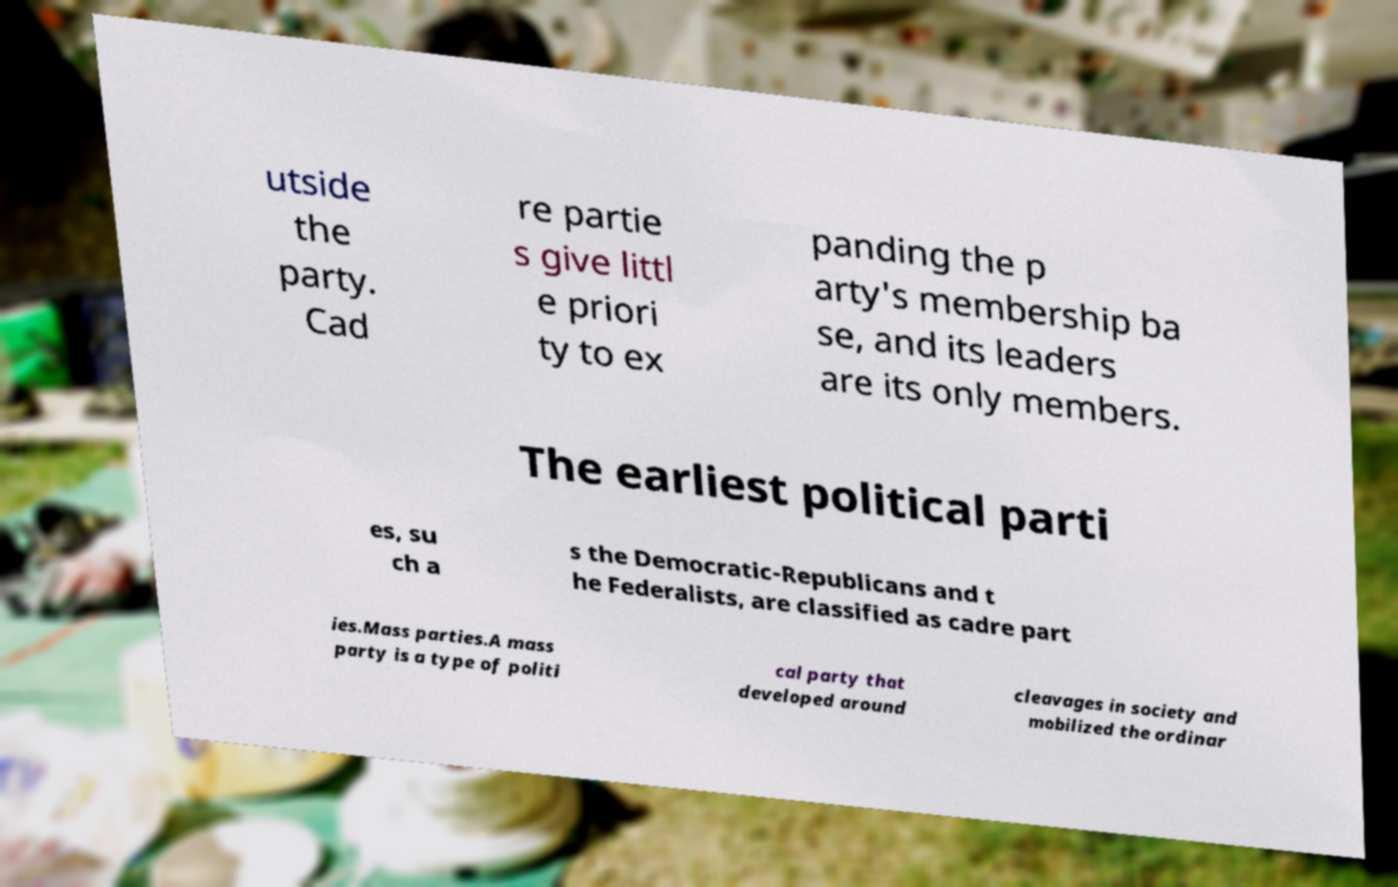Could you extract and type out the text from this image? utside the party. Cad re partie s give littl e priori ty to ex panding the p arty's membership ba se, and its leaders are its only members. The earliest political parti es, su ch a s the Democratic-Republicans and t he Federalists, are classified as cadre part ies.Mass parties.A mass party is a type of politi cal party that developed around cleavages in society and mobilized the ordinar 